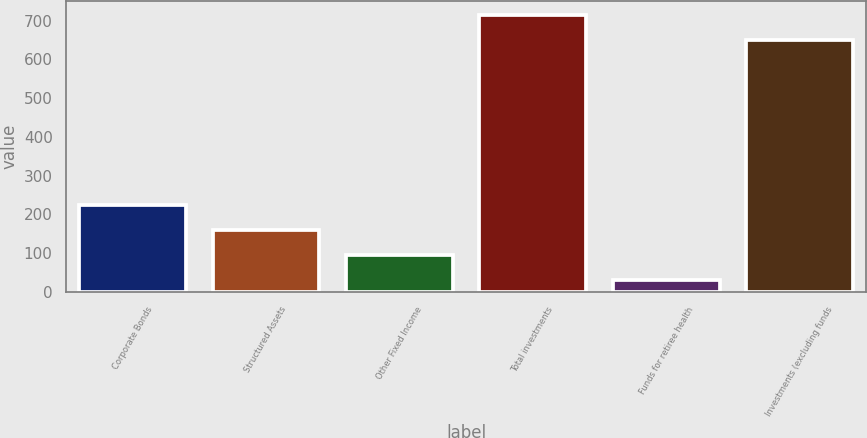Convert chart to OTSL. <chart><loc_0><loc_0><loc_500><loc_500><bar_chart><fcel>Corporate Bonds<fcel>Structured Assets<fcel>Other Fixed Income<fcel>Total investments<fcel>Funds for retiree health<fcel>Investments (excluding funds<nl><fcel>225<fcel>160<fcel>95<fcel>715<fcel>30<fcel>650<nl></chart> 